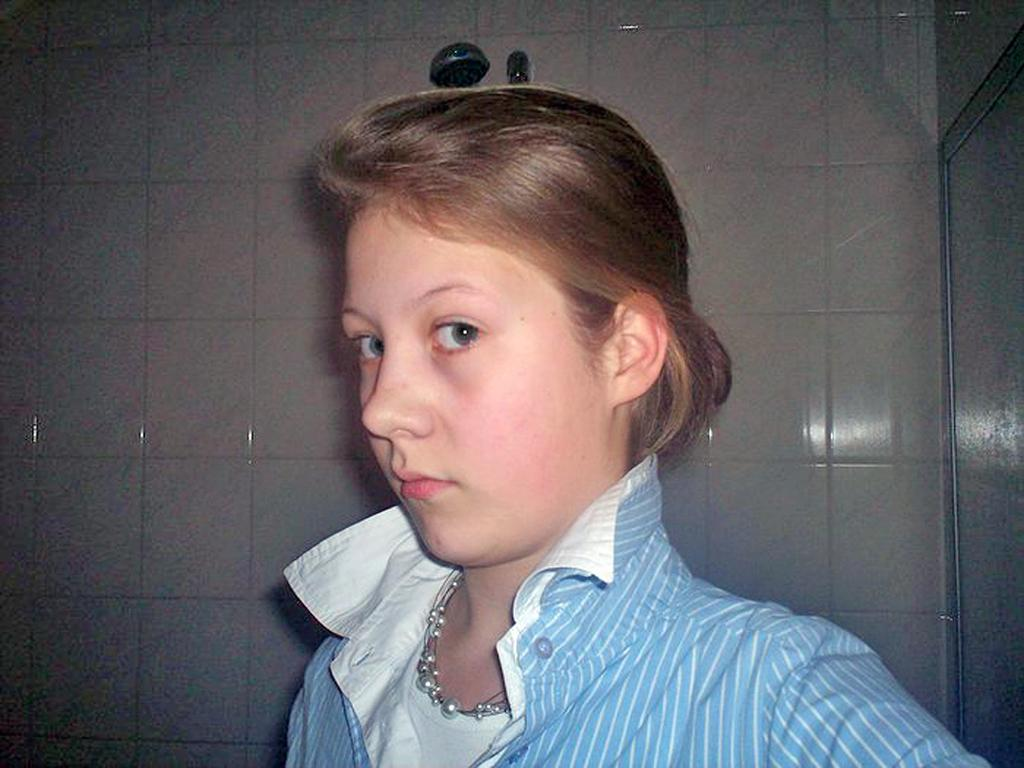Who is the main subject in the image? There is a girl in the image. What is the girl wearing? The girl is wearing a blue and white shirt and a pearls necklace. What can be seen in the background of the image? There are white tiles in the background. What activity is the girl likely to be engaged in? The presence of a shower in the image suggests that the girl might be taking a shower. How many chickens are present in the image? There are no chickens present in the image. What type of page is the girl holding in the image? There is no page visible in the image. 